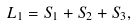Convert formula to latex. <formula><loc_0><loc_0><loc_500><loc_500>& L _ { 1 } = S _ { 1 } + S _ { 2 } + S _ { 3 } ,</formula> 